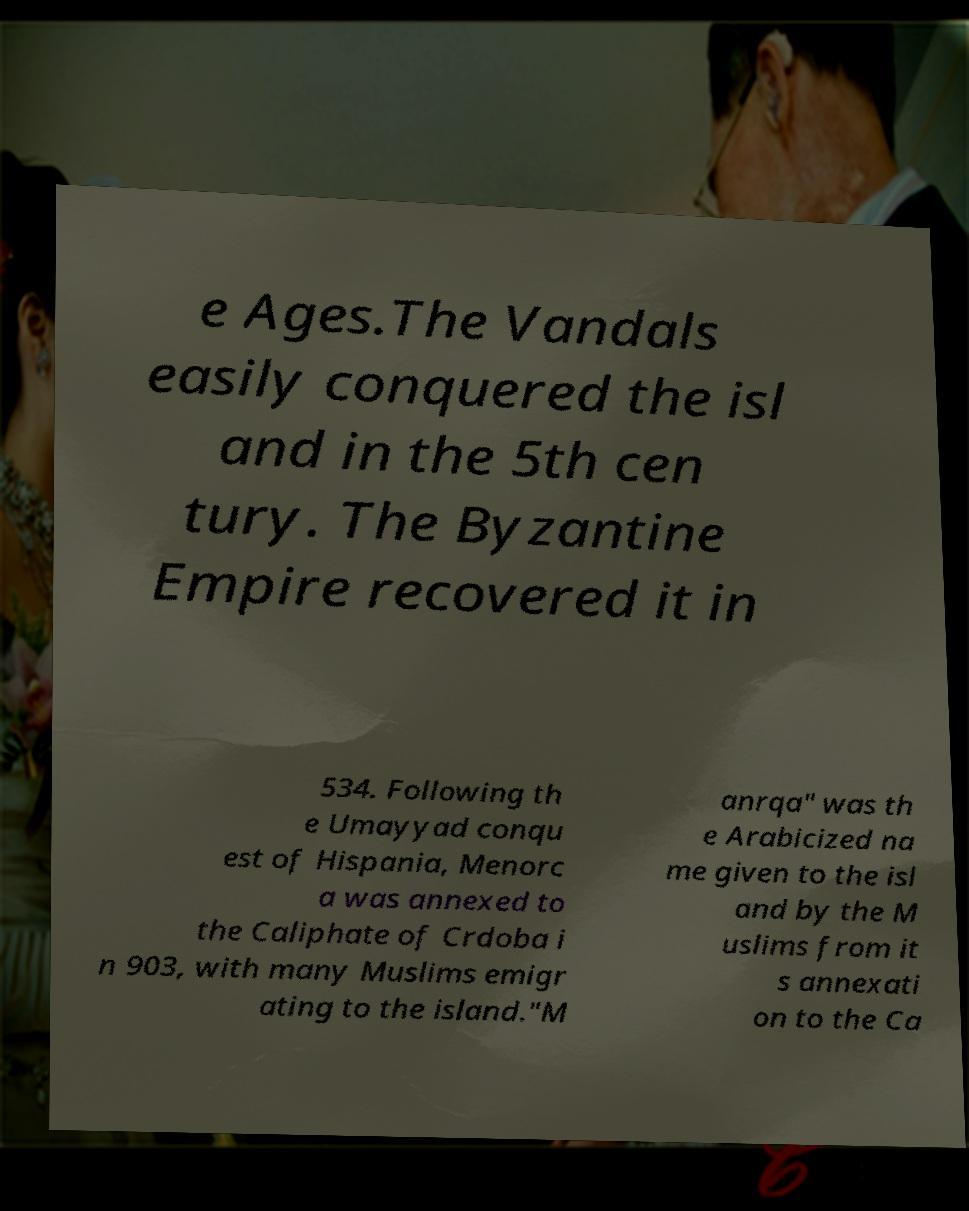There's text embedded in this image that I need extracted. Can you transcribe it verbatim? e Ages.The Vandals easily conquered the isl and in the 5th cen tury. The Byzantine Empire recovered it in 534. Following th e Umayyad conqu est of Hispania, Menorc a was annexed to the Caliphate of Crdoba i n 903, with many Muslims emigr ating to the island."M anrqa" was th e Arabicized na me given to the isl and by the M uslims from it s annexati on to the Ca 